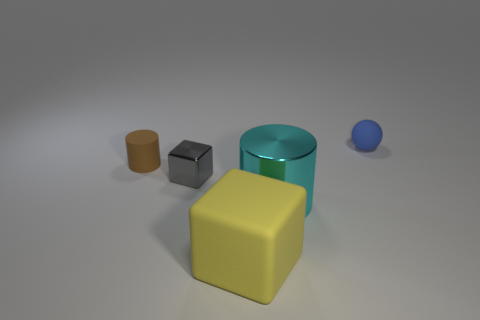Add 4 blue rubber objects. How many objects exist? 9 Subtract all cubes. How many objects are left? 3 Subtract 0 blue cylinders. How many objects are left? 5 Subtract all large cubes. Subtract all small brown rubber things. How many objects are left? 3 Add 5 big yellow matte blocks. How many big yellow matte blocks are left? 6 Add 1 tiny rubber things. How many tiny rubber things exist? 3 